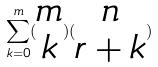<formula> <loc_0><loc_0><loc_500><loc_500>\sum _ { k = 0 } ^ { m } ( \begin{matrix} m \\ k \end{matrix} ) ( \begin{matrix} n \\ r + k \end{matrix} )</formula> 